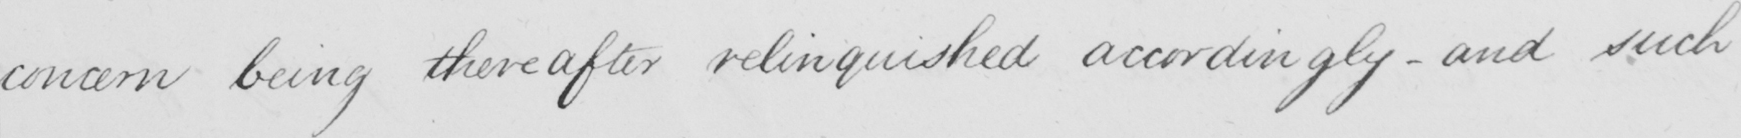Transcribe the text shown in this historical manuscript line. concern being thereafter relinquished accordingly  _  and such 